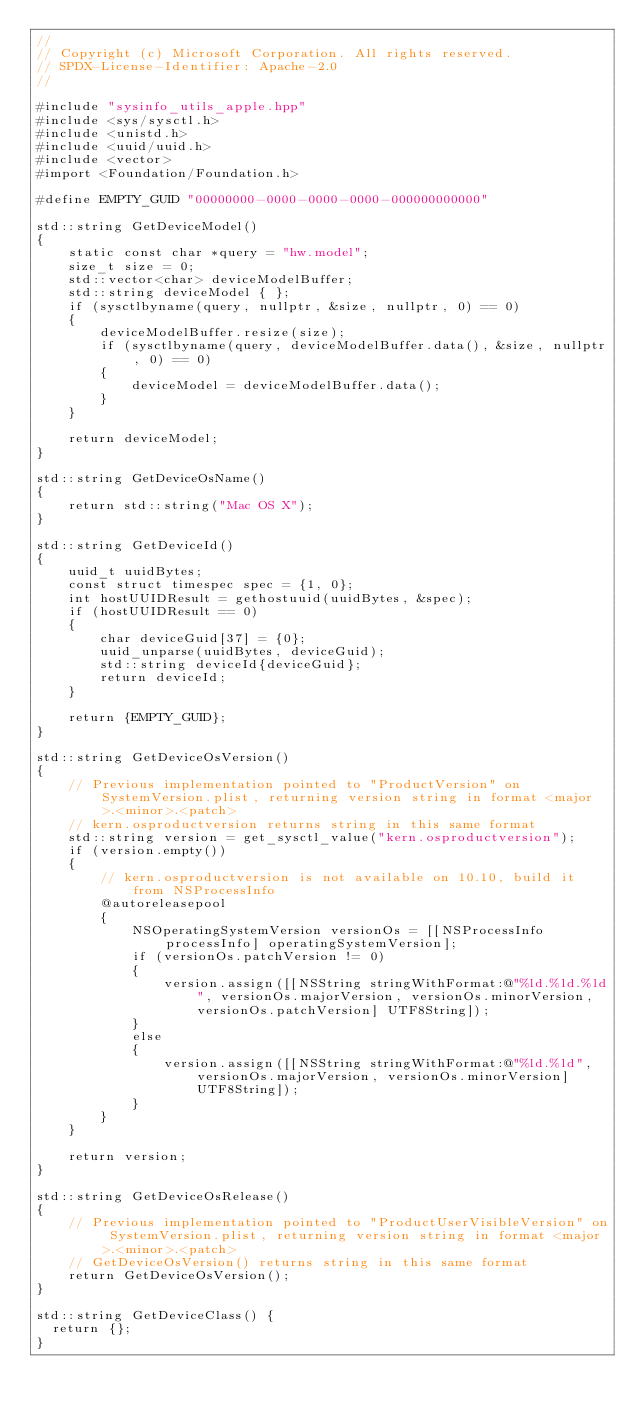Convert code to text. <code><loc_0><loc_0><loc_500><loc_500><_ObjectiveC_>//
// Copyright (c) Microsoft Corporation. All rights reserved.
// SPDX-License-Identifier: Apache-2.0
//

#include "sysinfo_utils_apple.hpp"
#include <sys/sysctl.h>
#include <unistd.h>
#include <uuid/uuid.h>
#include <vector>
#import <Foundation/Foundation.h>

#define EMPTY_GUID "00000000-0000-0000-0000-000000000000"

std::string GetDeviceModel()
{
    static const char *query = "hw.model";
    size_t size = 0;
    std::vector<char> deviceModelBuffer;
    std::string deviceModel { };
    if (sysctlbyname(query, nullptr, &size, nullptr, 0) == 0)
    {
        deviceModelBuffer.resize(size);
        if (sysctlbyname(query, deviceModelBuffer.data(), &size, nullptr, 0) == 0)
        {
            deviceModel = deviceModelBuffer.data();
        }
    }

    return deviceModel;
}

std::string GetDeviceOsName()
{
    return std::string("Mac OS X");
}

std::string GetDeviceId()
{
    uuid_t uuidBytes;
    const struct timespec spec = {1, 0};
    int hostUUIDResult = gethostuuid(uuidBytes, &spec);
    if (hostUUIDResult == 0)
    {
        char deviceGuid[37] = {0};
        uuid_unparse(uuidBytes, deviceGuid);
        std::string deviceId{deviceGuid};
        return deviceId;
    }

    return {EMPTY_GUID};
}

std::string GetDeviceOsVersion()
{
    // Previous implementation pointed to "ProductVersion" on SystemVersion.plist, returning version string in format <major>.<minor>.<patch>
    // kern.osproductversion returns string in this same format
    std::string version = get_sysctl_value("kern.osproductversion");
    if (version.empty())
    {
        // kern.osproductversion is not available on 10.10, build it from NSProcessInfo
        @autoreleasepool
        {
            NSOperatingSystemVersion versionOs = [[NSProcessInfo processInfo] operatingSystemVersion];
            if (versionOs.patchVersion != 0)
            {
                version.assign([[NSString stringWithFormat:@"%ld.%ld.%ld", versionOs.majorVersion, versionOs.minorVersion, versionOs.patchVersion] UTF8String]);
            }
            else
            {
                version.assign([[NSString stringWithFormat:@"%ld.%ld", versionOs.majorVersion, versionOs.minorVersion] UTF8String]);
            }
        }
    }
    
    return version;
}

std::string GetDeviceOsRelease()
{
    // Previous implementation pointed to "ProductUserVisibleVersion" on SystemVersion.plist, returning version string in format <major>.<minor>.<patch>
    // GetDeviceOsVersion() returns string in this same format
    return GetDeviceOsVersion();
}

std::string GetDeviceClass() {
  return {};
}
</code> 